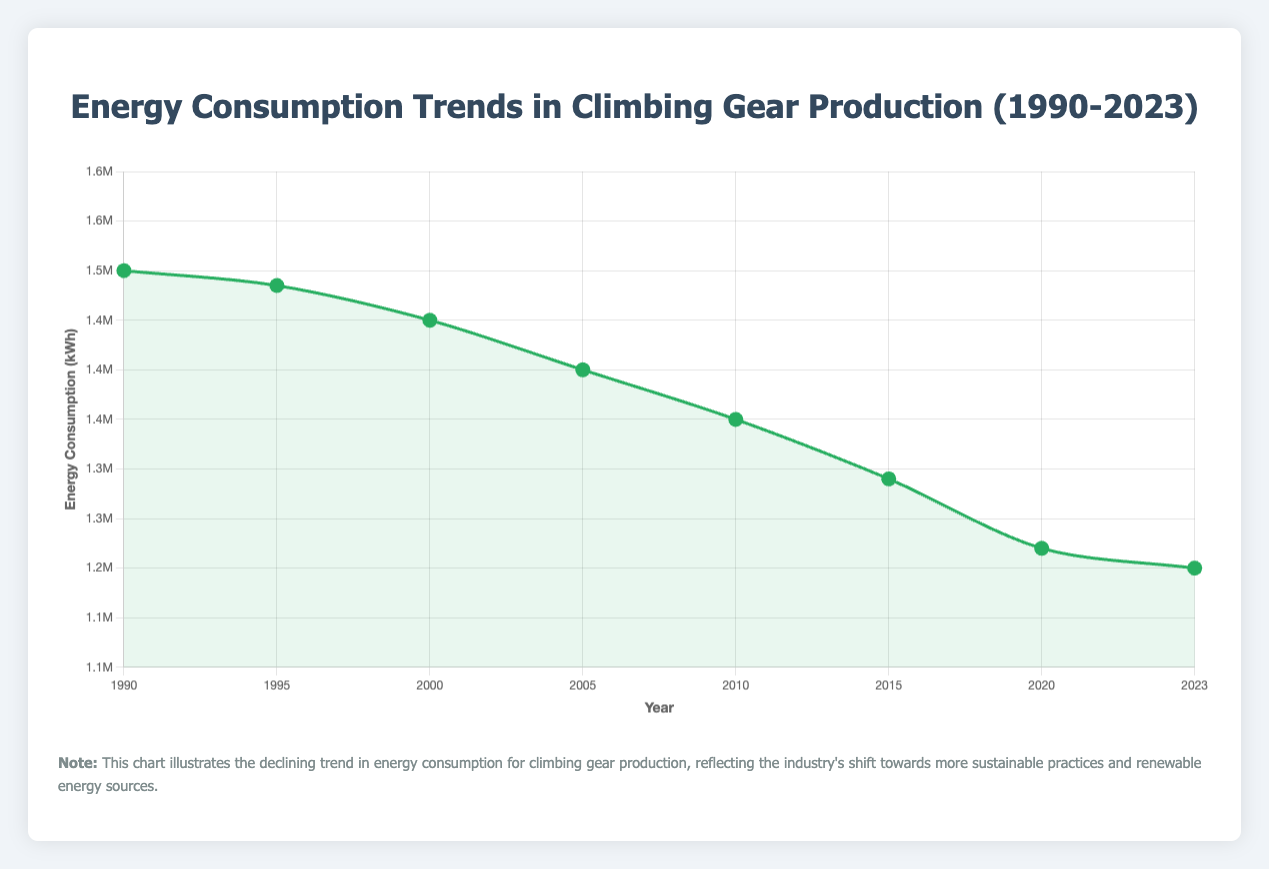What is the overall trend in energy consumption from 1990 to 2023? The trend shows a decrease in energy consumption over the years. The energy consumption gradually declines from 1,500,000 kWh in 1990 to 1,200,000 kWh in 2023, indicating an ongoing effort to improve energy efficiency and adopt renewable energy sources.
Answer: Decreasing In which year did the energy consumption drop below 1,300,000 kWh for the first time? The chart shows that in 2015, the energy consumption dropped to 1,290,000 kWh, marking the first year it fell below 1,300,000 kWh.
Answer: 2015 How many energy consumption declines occurred during the period 1990-2023? The energy consumption decreased in the following years: 1995, 2000, 2005, 2010, 2015, 2020, and 2023. Counting these events gives a total of 7 declines.
Answer: 7 Compare the energy sources used in 1990 and 2023, and explain the shift in energy policy. In 1990, the primary energy sources were Coal and Natural Gas, both non-renewable. By 2023, the primary sources had shifted entirely to renewable energy, specifically Solar, Wind, and Hydropower, indicating a substantial move towards sustainability.
Answer: Shift from non-renewable to renewable energy What is the average annual energy consumption between 1990 and 2023? Summing the energy values from 1990 to 2023 (1,500,000 + 1,485,000 + 1,450,000 + 1,400,000 + 1,350,000 + 1,290,000 + 1,220,000 + 1,200,000) results in 10,895,000 kWh. There are 8 data points, so the average annual energy consumption is 10,895,000 / 8 = 1,361,875 kWh.
Answer: 1,361,875 kWh Which year had the largest decrease in energy consumption compared to the previous one, and what was the decrease amount? Observing the differences each year, the largest decrease happened between 2015 and 2020. The energy consumption dropped from 1,290,000 kWh in 2015 to 1,220,000 kWh in 2020, a decrease of 70,000 kWh.
Answer: 2015 to 2020, 70,000 kWh What visual cues in the chart indicate the increasing adoption of renewable energy over the years? The chart shows a downward trend in energy consumption, combined with changes in energy notes and sources. Initial notes mention high reliance on non-renewable sources, with later years indicating a shift to renewable energy, supported visually by the green line and background.
Answer: Downward trend and changing notes How did the number of major companies involved in climbing gear production change from 1990 to 2023? In 1990, there were 2 major companies involved. By 2023, this number increased to 9 major companies, suggesting expansion in the industry.
Answer: Increased from 2 to 9 What was the specific transition in primary energy sources between 2010 and 2015? In 2010, the primary energy sources included Natural Gas, Oil, Solar, and Wind. By 2015, the use of Oil had dropped and the focus was on Natural Gas, Solar, and Wind, indicating a reduction in non-renewable sources.
Answer: Reduction in Oil usage What is the total reduction in energy consumption from 1990 to 2023? The initial energy consumption in 1990 was 1,500,000 kWh, and it fell to 1,200,000 kWh in 2023. Therefore, the total reduction is 1,500,000 - 1,200,000 = 300,000 kWh.
Answer: 300,000 kWh 